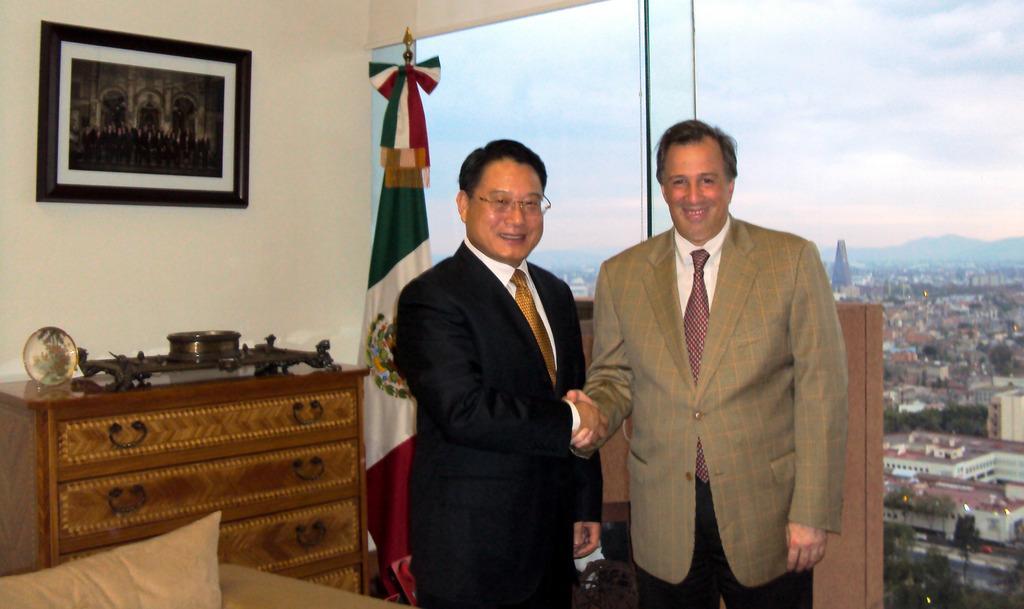Describe this image in one or two sentences. In this picture we can see two persons standing in the middle. They wear a suit. And he has spectacles. And on the background there is a wall. And this is the frame. This is the cupboard. And here we can see the view of a city from the glass. This is the sky. 